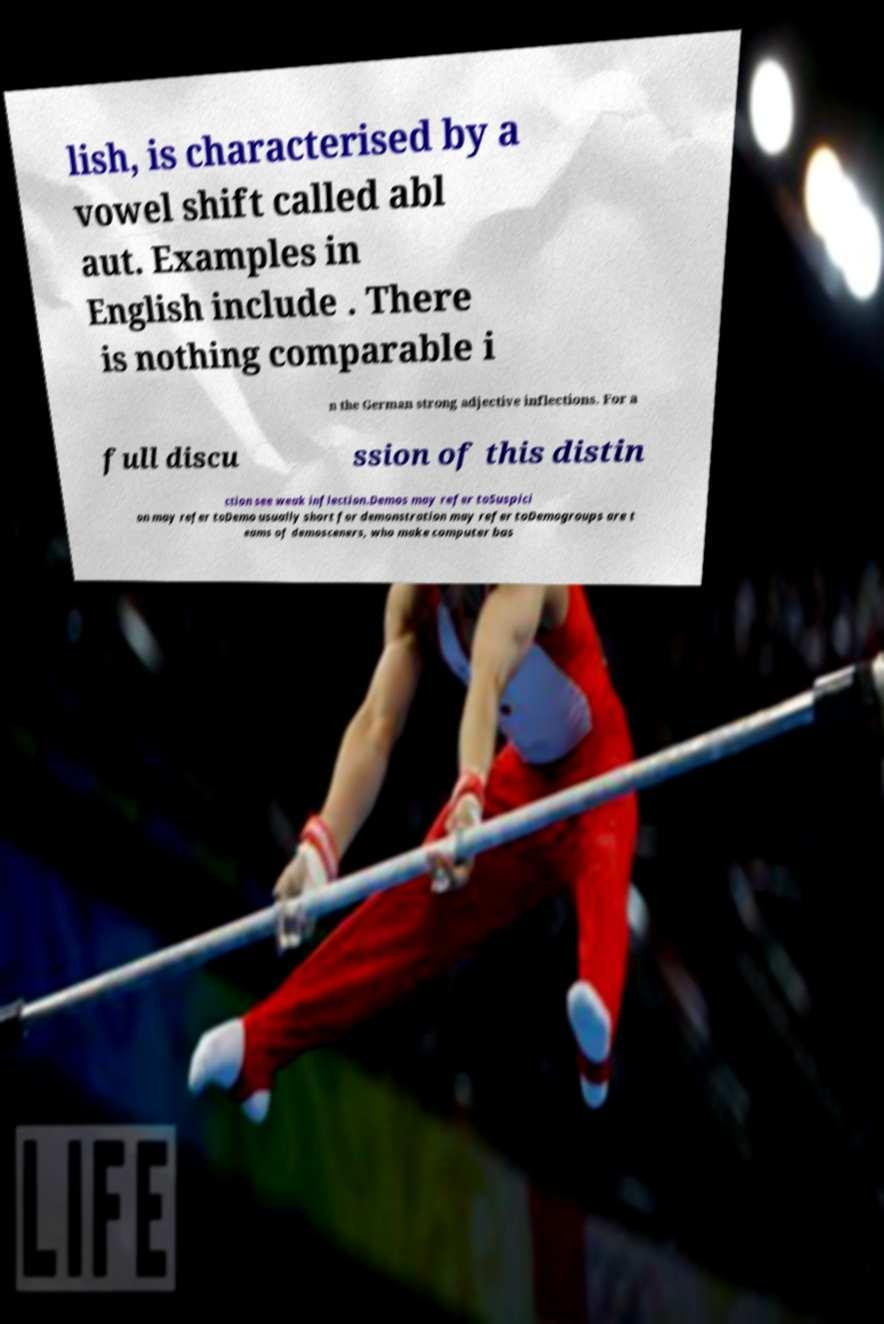Please read and relay the text visible in this image. What does it say? lish, is characterised by a vowel shift called abl aut. Examples in English include . There is nothing comparable i n the German strong adjective inflections. For a full discu ssion of this distin ction see weak inflection.Demos may refer toSuspici on may refer toDemo usually short for demonstration may refer toDemogroups are t eams of demosceners, who make computer bas 